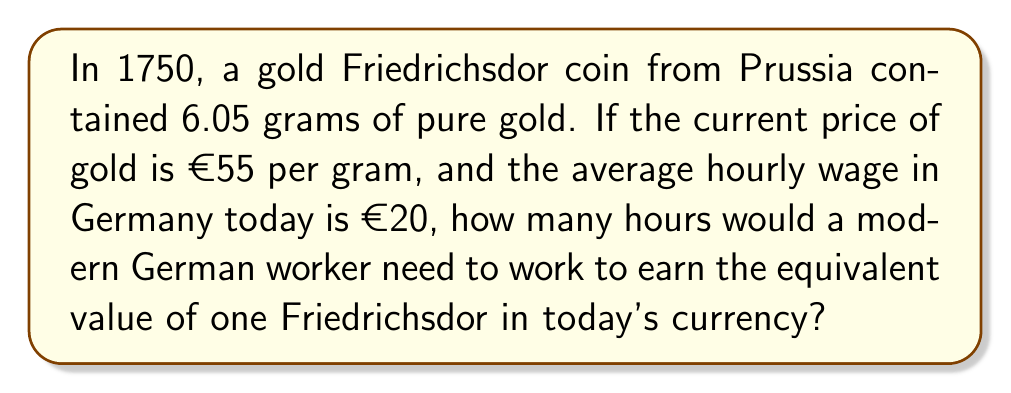Help me with this question. Let's break this down step-by-step:

1. Calculate the value of the Friedrichsdor in today's currency:
   Gold content = 6.05 grams
   Current gold price = €55 per gram
   Value = $6.05 \times €55 = €332.75$

2. Calculate how many hours of work are needed to earn this amount:
   Modern hourly wage = €20
   Hours needed = $\frac{\text{Value of coin}}{\text{Hourly wage}}$
   
   $$\text{Hours} = \frac{€332.75}{€20/\text{hour}} = 16.6375 \text{ hours}$$

3. Round to the nearest quarter hour:
   16.6375 hours ≈ 16.75 hours or 16 hours and 45 minutes
Answer: 16.75 hours 